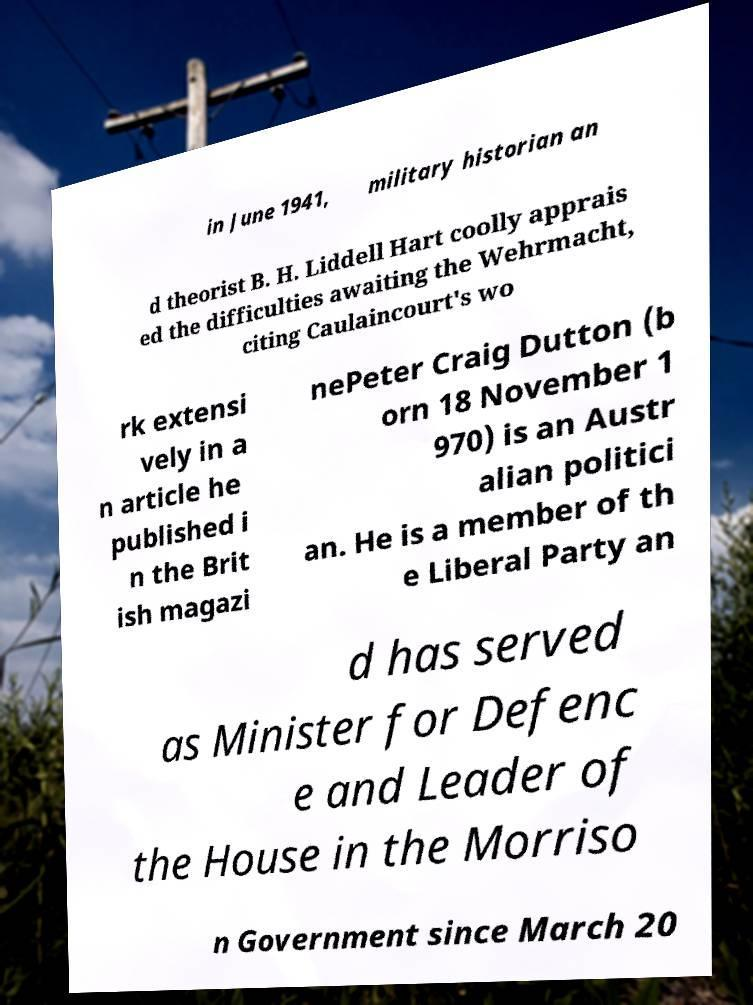What messages or text are displayed in this image? I need them in a readable, typed format. in June 1941, military historian an d theorist B. H. Liddell Hart coolly apprais ed the difficulties awaiting the Wehrmacht, citing Caulaincourt's wo rk extensi vely in a n article he published i n the Brit ish magazi nePeter Craig Dutton (b orn 18 November 1 970) is an Austr alian politici an. He is a member of th e Liberal Party an d has served as Minister for Defenc e and Leader of the House in the Morriso n Government since March 20 